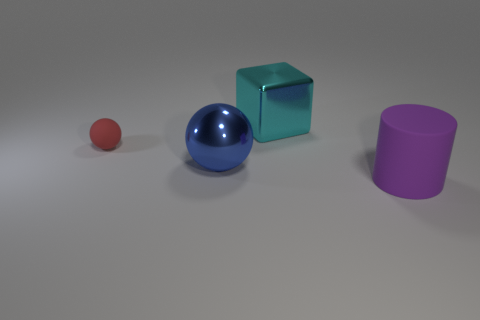Is there any other thing that has the same shape as the big matte object?
Keep it short and to the point. No. What is the color of the object that is behind the blue metal thing and in front of the big metal block?
Offer a very short reply. Red. Does the matte object behind the purple thing have the same size as the large purple matte object?
Offer a very short reply. No. There is a metal object that is to the left of the metallic cube; is there a object behind it?
Your answer should be very brief. Yes. What is the cylinder made of?
Offer a terse response. Rubber. There is a large blue sphere; are there any things behind it?
Offer a very short reply. Yes. The red rubber thing that is the same shape as the blue shiny thing is what size?
Ensure brevity in your answer.  Small. Is the number of cyan metal things that are behind the small red object the same as the number of purple rubber things that are left of the cyan metallic thing?
Ensure brevity in your answer.  No. How many large blue balls are there?
Offer a terse response. 1. Is the number of purple objects to the right of the big blue metallic ball greater than the number of big yellow metallic cylinders?
Your answer should be very brief. Yes. 